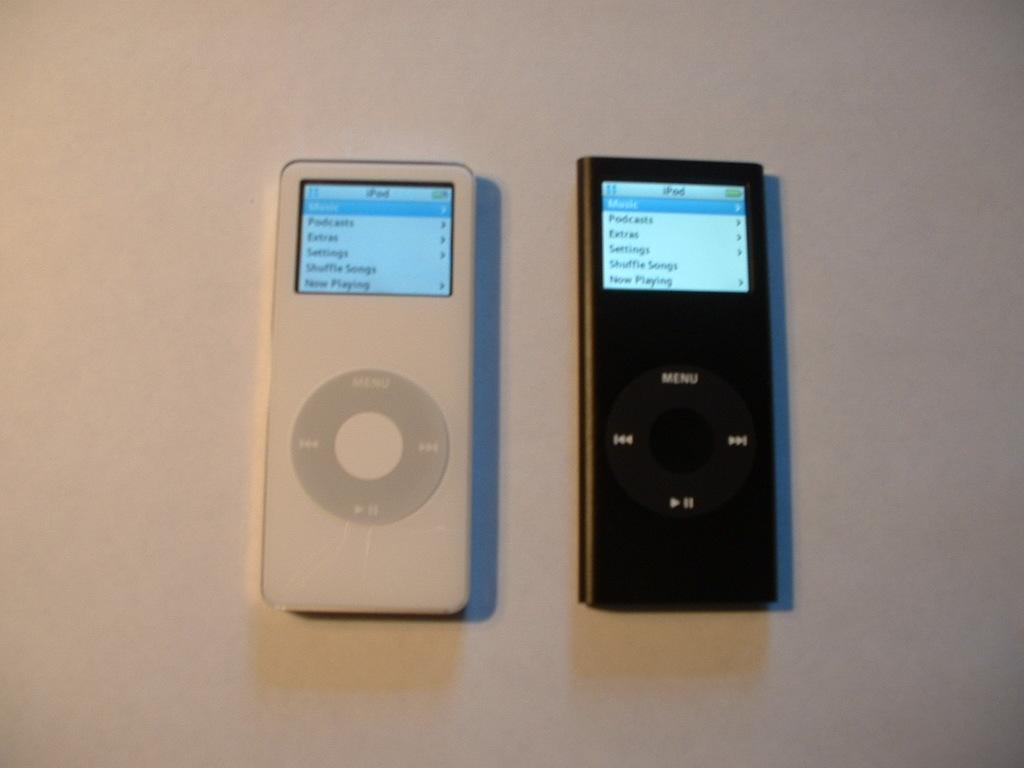What electronic devices are present in the image? There are two iPods in the image. What colors are the iPods? The iPods are black and white in color. Where are the iPods located in the image? The iPods are placed on a white table. What type of chair is visible in the image? There is no chair present in the image; it only features two iPods on a white table. 